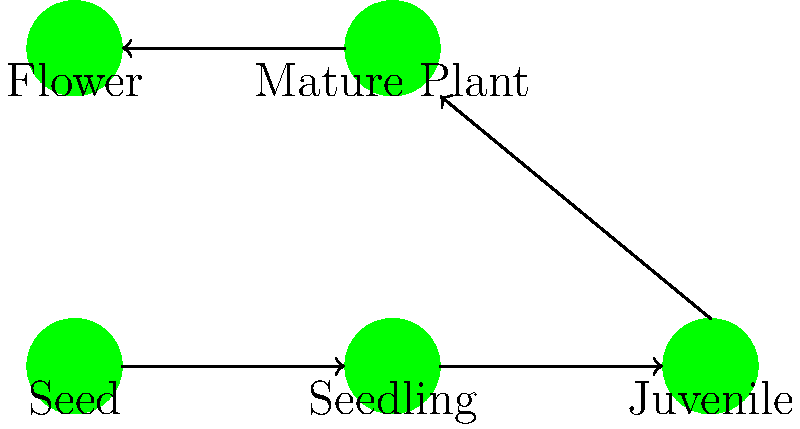Examine the life cycle diagram of a native Andaman orchid species. Which stage in the cycle represents the transition from a non-reproductive to a reproductive phase, and what physiological changes occur during this stage? To answer this question, let's analyze the life cycle diagram step-by-step:

1. The diagram shows five main stages: Seed, Seedling, Juvenile, Mature Plant, and Flower.

2. The transition from non-reproductive to reproductive phase occurs between the Juvenile and Mature Plant stages.

3. This transition is represented by the "Maturation" arrow in the diagram.

4. During the maturation stage, several physiological changes occur:

   a) Development of reproductive structures: The orchid begins to form flower buds and develops its reproductive organs (stamens and pistils).
   
   b) Hormonal changes: There's an increase in flowering hormones like florigen, which triggers the transition to the reproductive phase.
   
   c) Energy allocation: The plant shifts its energy resources from purely vegetative growth to supporting reproductive structures.
   
   d) Structural changes: The orchid may develop specialized leaves or pseudobulbs to support flowering.
   
   e) Root system development: The roots become more extensive to support the increased nutrient demands of flowering.

5. After maturation, the plant enters the Mature Plant stage, where it can produce flowers and complete its reproductive cycle.

The key physiological change is the development of reproductive structures and the hormonal shift that enables flowering.
Answer: Maturation stage; development of reproductive structures and hormonal changes enabling flowering. 